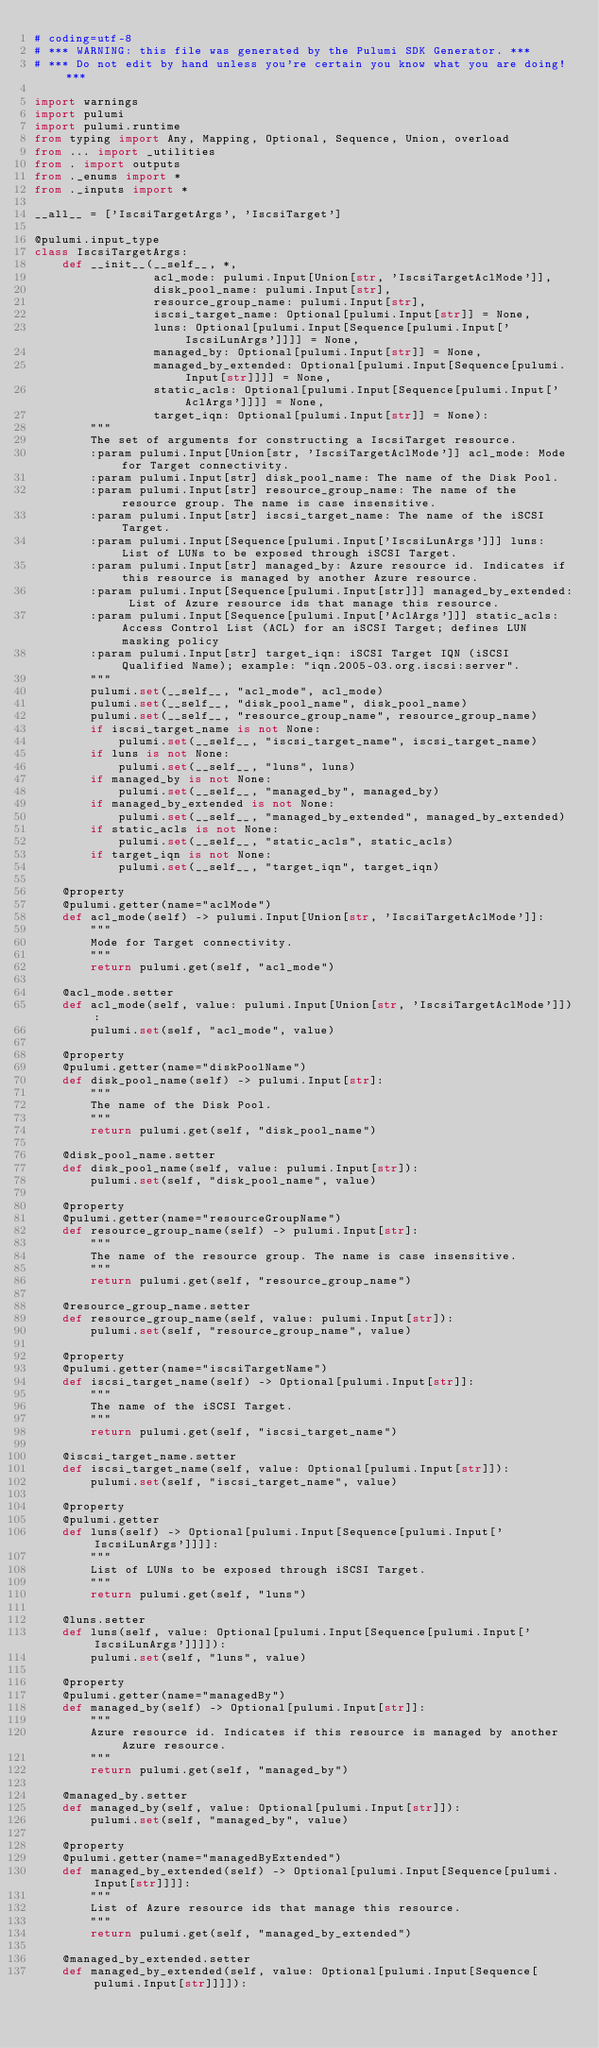Convert code to text. <code><loc_0><loc_0><loc_500><loc_500><_Python_># coding=utf-8
# *** WARNING: this file was generated by the Pulumi SDK Generator. ***
# *** Do not edit by hand unless you're certain you know what you are doing! ***

import warnings
import pulumi
import pulumi.runtime
from typing import Any, Mapping, Optional, Sequence, Union, overload
from ... import _utilities
from . import outputs
from ._enums import *
from ._inputs import *

__all__ = ['IscsiTargetArgs', 'IscsiTarget']

@pulumi.input_type
class IscsiTargetArgs:
    def __init__(__self__, *,
                 acl_mode: pulumi.Input[Union[str, 'IscsiTargetAclMode']],
                 disk_pool_name: pulumi.Input[str],
                 resource_group_name: pulumi.Input[str],
                 iscsi_target_name: Optional[pulumi.Input[str]] = None,
                 luns: Optional[pulumi.Input[Sequence[pulumi.Input['IscsiLunArgs']]]] = None,
                 managed_by: Optional[pulumi.Input[str]] = None,
                 managed_by_extended: Optional[pulumi.Input[Sequence[pulumi.Input[str]]]] = None,
                 static_acls: Optional[pulumi.Input[Sequence[pulumi.Input['AclArgs']]]] = None,
                 target_iqn: Optional[pulumi.Input[str]] = None):
        """
        The set of arguments for constructing a IscsiTarget resource.
        :param pulumi.Input[Union[str, 'IscsiTargetAclMode']] acl_mode: Mode for Target connectivity.
        :param pulumi.Input[str] disk_pool_name: The name of the Disk Pool.
        :param pulumi.Input[str] resource_group_name: The name of the resource group. The name is case insensitive.
        :param pulumi.Input[str] iscsi_target_name: The name of the iSCSI Target.
        :param pulumi.Input[Sequence[pulumi.Input['IscsiLunArgs']]] luns: List of LUNs to be exposed through iSCSI Target.
        :param pulumi.Input[str] managed_by: Azure resource id. Indicates if this resource is managed by another Azure resource.
        :param pulumi.Input[Sequence[pulumi.Input[str]]] managed_by_extended: List of Azure resource ids that manage this resource.
        :param pulumi.Input[Sequence[pulumi.Input['AclArgs']]] static_acls: Access Control List (ACL) for an iSCSI Target; defines LUN masking policy
        :param pulumi.Input[str] target_iqn: iSCSI Target IQN (iSCSI Qualified Name); example: "iqn.2005-03.org.iscsi:server".
        """
        pulumi.set(__self__, "acl_mode", acl_mode)
        pulumi.set(__self__, "disk_pool_name", disk_pool_name)
        pulumi.set(__self__, "resource_group_name", resource_group_name)
        if iscsi_target_name is not None:
            pulumi.set(__self__, "iscsi_target_name", iscsi_target_name)
        if luns is not None:
            pulumi.set(__self__, "luns", luns)
        if managed_by is not None:
            pulumi.set(__self__, "managed_by", managed_by)
        if managed_by_extended is not None:
            pulumi.set(__self__, "managed_by_extended", managed_by_extended)
        if static_acls is not None:
            pulumi.set(__self__, "static_acls", static_acls)
        if target_iqn is not None:
            pulumi.set(__self__, "target_iqn", target_iqn)

    @property
    @pulumi.getter(name="aclMode")
    def acl_mode(self) -> pulumi.Input[Union[str, 'IscsiTargetAclMode']]:
        """
        Mode for Target connectivity.
        """
        return pulumi.get(self, "acl_mode")

    @acl_mode.setter
    def acl_mode(self, value: pulumi.Input[Union[str, 'IscsiTargetAclMode']]):
        pulumi.set(self, "acl_mode", value)

    @property
    @pulumi.getter(name="diskPoolName")
    def disk_pool_name(self) -> pulumi.Input[str]:
        """
        The name of the Disk Pool.
        """
        return pulumi.get(self, "disk_pool_name")

    @disk_pool_name.setter
    def disk_pool_name(self, value: pulumi.Input[str]):
        pulumi.set(self, "disk_pool_name", value)

    @property
    @pulumi.getter(name="resourceGroupName")
    def resource_group_name(self) -> pulumi.Input[str]:
        """
        The name of the resource group. The name is case insensitive.
        """
        return pulumi.get(self, "resource_group_name")

    @resource_group_name.setter
    def resource_group_name(self, value: pulumi.Input[str]):
        pulumi.set(self, "resource_group_name", value)

    @property
    @pulumi.getter(name="iscsiTargetName")
    def iscsi_target_name(self) -> Optional[pulumi.Input[str]]:
        """
        The name of the iSCSI Target.
        """
        return pulumi.get(self, "iscsi_target_name")

    @iscsi_target_name.setter
    def iscsi_target_name(self, value: Optional[pulumi.Input[str]]):
        pulumi.set(self, "iscsi_target_name", value)

    @property
    @pulumi.getter
    def luns(self) -> Optional[pulumi.Input[Sequence[pulumi.Input['IscsiLunArgs']]]]:
        """
        List of LUNs to be exposed through iSCSI Target.
        """
        return pulumi.get(self, "luns")

    @luns.setter
    def luns(self, value: Optional[pulumi.Input[Sequence[pulumi.Input['IscsiLunArgs']]]]):
        pulumi.set(self, "luns", value)

    @property
    @pulumi.getter(name="managedBy")
    def managed_by(self) -> Optional[pulumi.Input[str]]:
        """
        Azure resource id. Indicates if this resource is managed by another Azure resource.
        """
        return pulumi.get(self, "managed_by")

    @managed_by.setter
    def managed_by(self, value: Optional[pulumi.Input[str]]):
        pulumi.set(self, "managed_by", value)

    @property
    @pulumi.getter(name="managedByExtended")
    def managed_by_extended(self) -> Optional[pulumi.Input[Sequence[pulumi.Input[str]]]]:
        """
        List of Azure resource ids that manage this resource.
        """
        return pulumi.get(self, "managed_by_extended")

    @managed_by_extended.setter
    def managed_by_extended(self, value: Optional[pulumi.Input[Sequence[pulumi.Input[str]]]]):</code> 